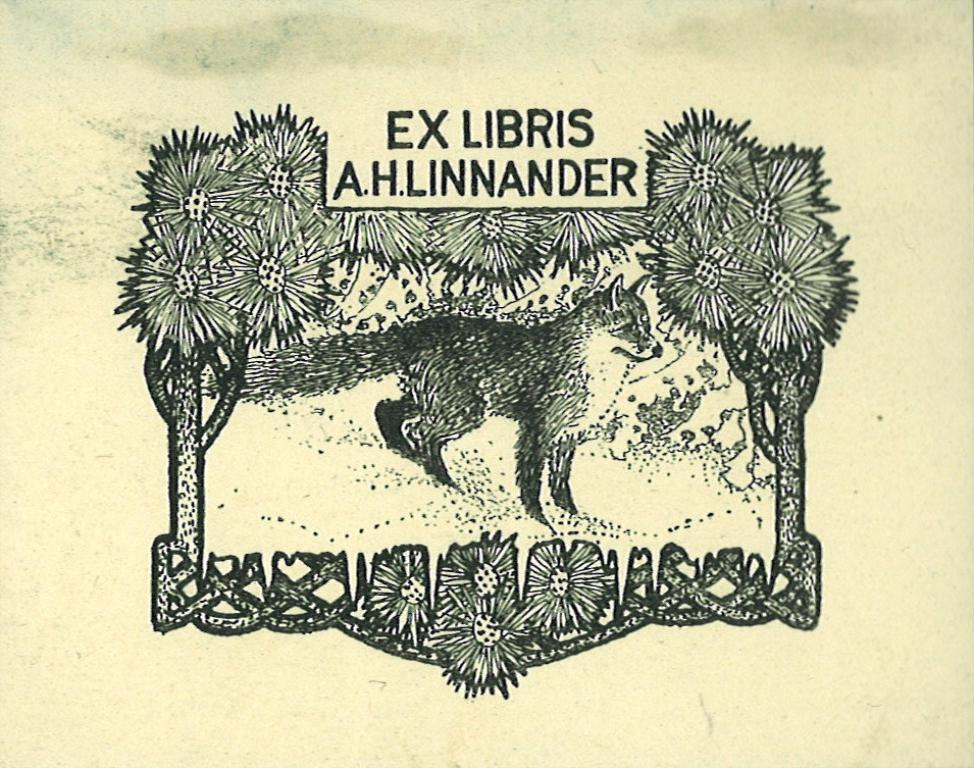What is the main subject of the poster in the image? The poster has a cartoon image of a fox and trees. Where is the text located on the poster? The text is written at the top of the poster. What type of line is used to draw the fox on the poster? There is no information about the type of line used to draw the fox on the poster. How many quinces are depicted in the poster? There are no quinces depicted in the poster; it features a cartoon image of a fox and trees. 